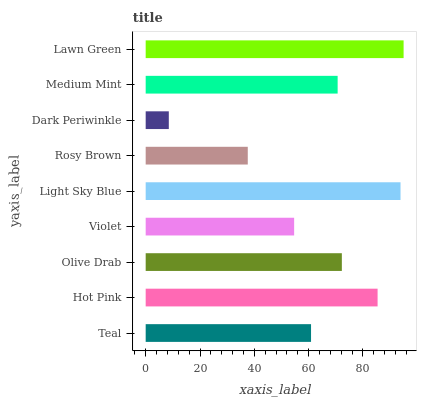Is Dark Periwinkle the minimum?
Answer yes or no. Yes. Is Lawn Green the maximum?
Answer yes or no. Yes. Is Hot Pink the minimum?
Answer yes or no. No. Is Hot Pink the maximum?
Answer yes or no. No. Is Hot Pink greater than Teal?
Answer yes or no. Yes. Is Teal less than Hot Pink?
Answer yes or no. Yes. Is Teal greater than Hot Pink?
Answer yes or no. No. Is Hot Pink less than Teal?
Answer yes or no. No. Is Medium Mint the high median?
Answer yes or no. Yes. Is Medium Mint the low median?
Answer yes or no. Yes. Is Light Sky Blue the high median?
Answer yes or no. No. Is Violet the low median?
Answer yes or no. No. 